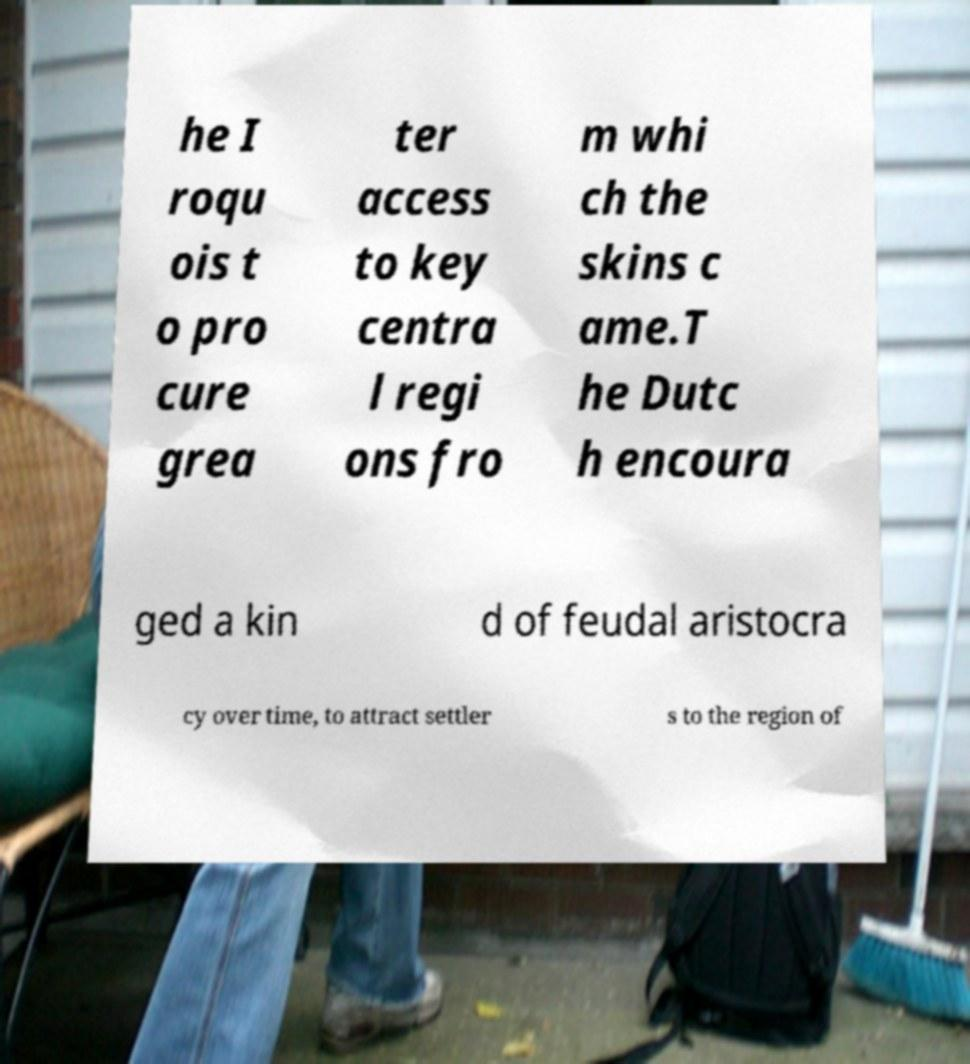Please identify and transcribe the text found in this image. he I roqu ois t o pro cure grea ter access to key centra l regi ons fro m whi ch the skins c ame.T he Dutc h encoura ged a kin d of feudal aristocra cy over time, to attract settler s to the region of 